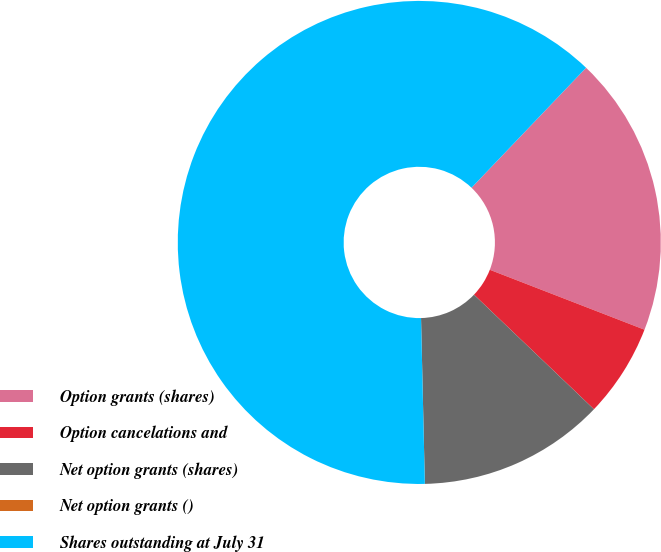Convert chart to OTSL. <chart><loc_0><loc_0><loc_500><loc_500><pie_chart><fcel>Option grants (shares)<fcel>Option cancelations and<fcel>Net option grants (shares)<fcel>Net option grants ()<fcel>Shares outstanding at July 31<nl><fcel>18.75%<fcel>6.25%<fcel>12.5%<fcel>0.0%<fcel>62.5%<nl></chart> 